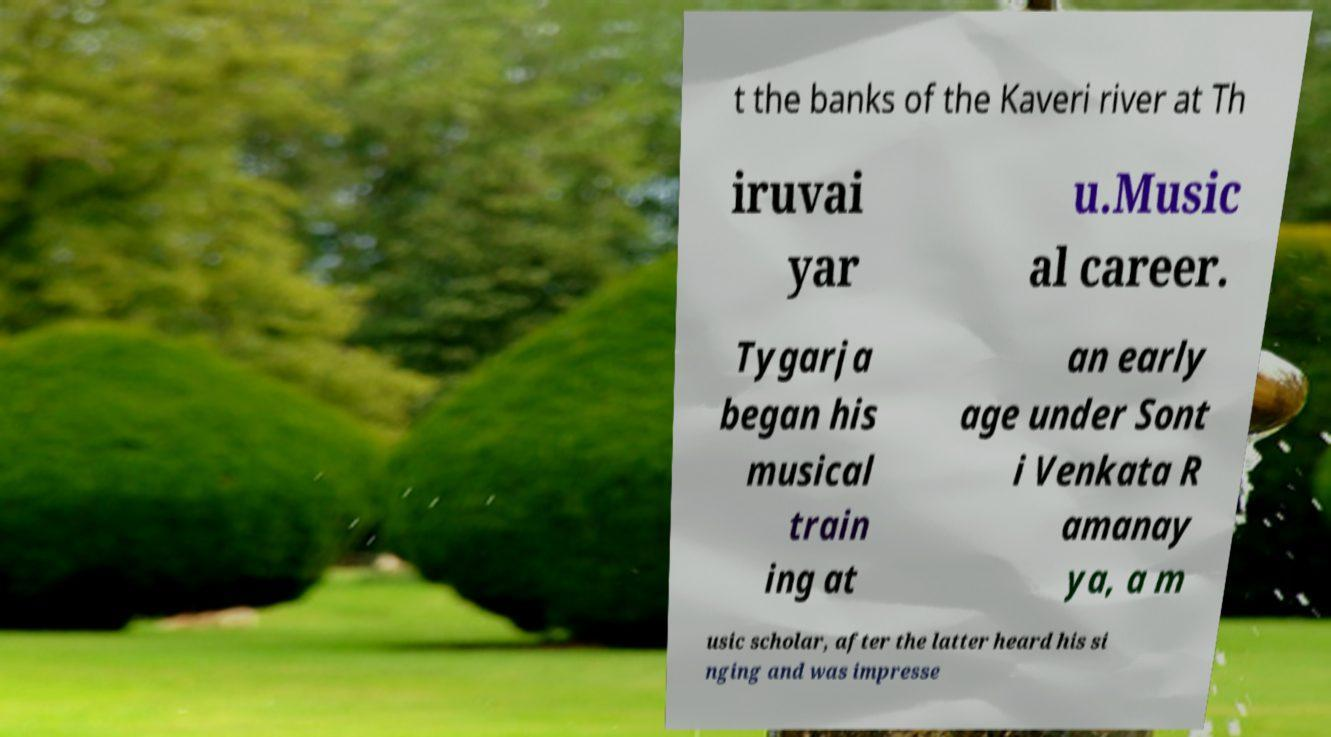Please read and relay the text visible in this image. What does it say? t the banks of the Kaveri river at Th iruvai yar u.Music al career. Tygarja began his musical train ing at an early age under Sont i Venkata R amanay ya, a m usic scholar, after the latter heard his si nging and was impresse 